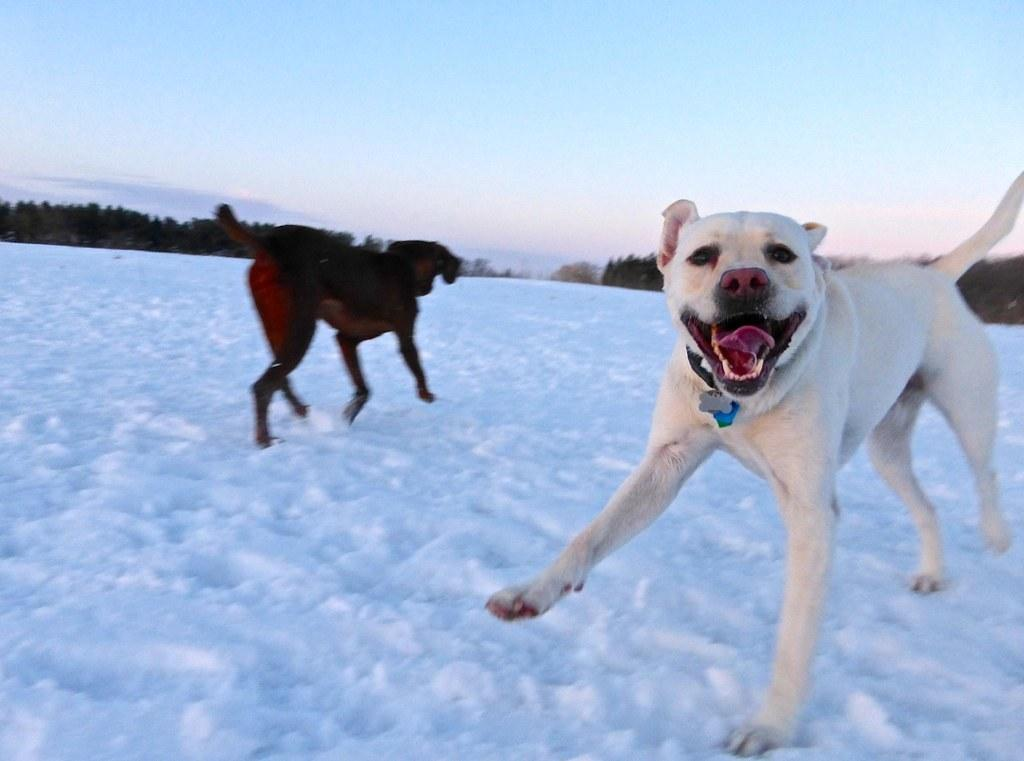What is covering the ground in the image? There is snow on the ground in the image. What animals can be seen in the image? There are dogs in the image. What are the colors of the dogs? The dogs have black, brown, and cream colors. What can be seen in the distance in the image? There are trees in the background of the image. What is visible above the trees in the image? The sky is visible in the background of the image. How much payment is required to enter the image? There is no payment required to enter the image, as it is a photograph or illustration and not a physical location. 